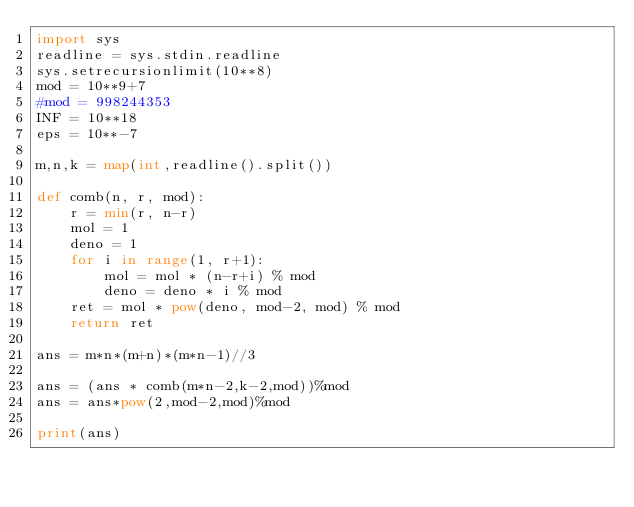<code> <loc_0><loc_0><loc_500><loc_500><_Python_>import sys
readline = sys.stdin.readline
sys.setrecursionlimit(10**8)
mod = 10**9+7
#mod = 998244353
INF = 10**18
eps = 10**-7

m,n,k = map(int,readline().split())

def comb(n, r, mod):
    r = min(r, n-r)
    mol = 1
    deno = 1
    for i in range(1, r+1):
        mol = mol * (n-r+i) % mod
        deno = deno * i % mod
    ret = mol * pow(deno, mod-2, mod) % mod
    return ret

ans = m*n*(m+n)*(m*n-1)//3

ans = (ans * comb(m*n-2,k-2,mod))%mod
ans = ans*pow(2,mod-2,mod)%mod

print(ans)

</code> 